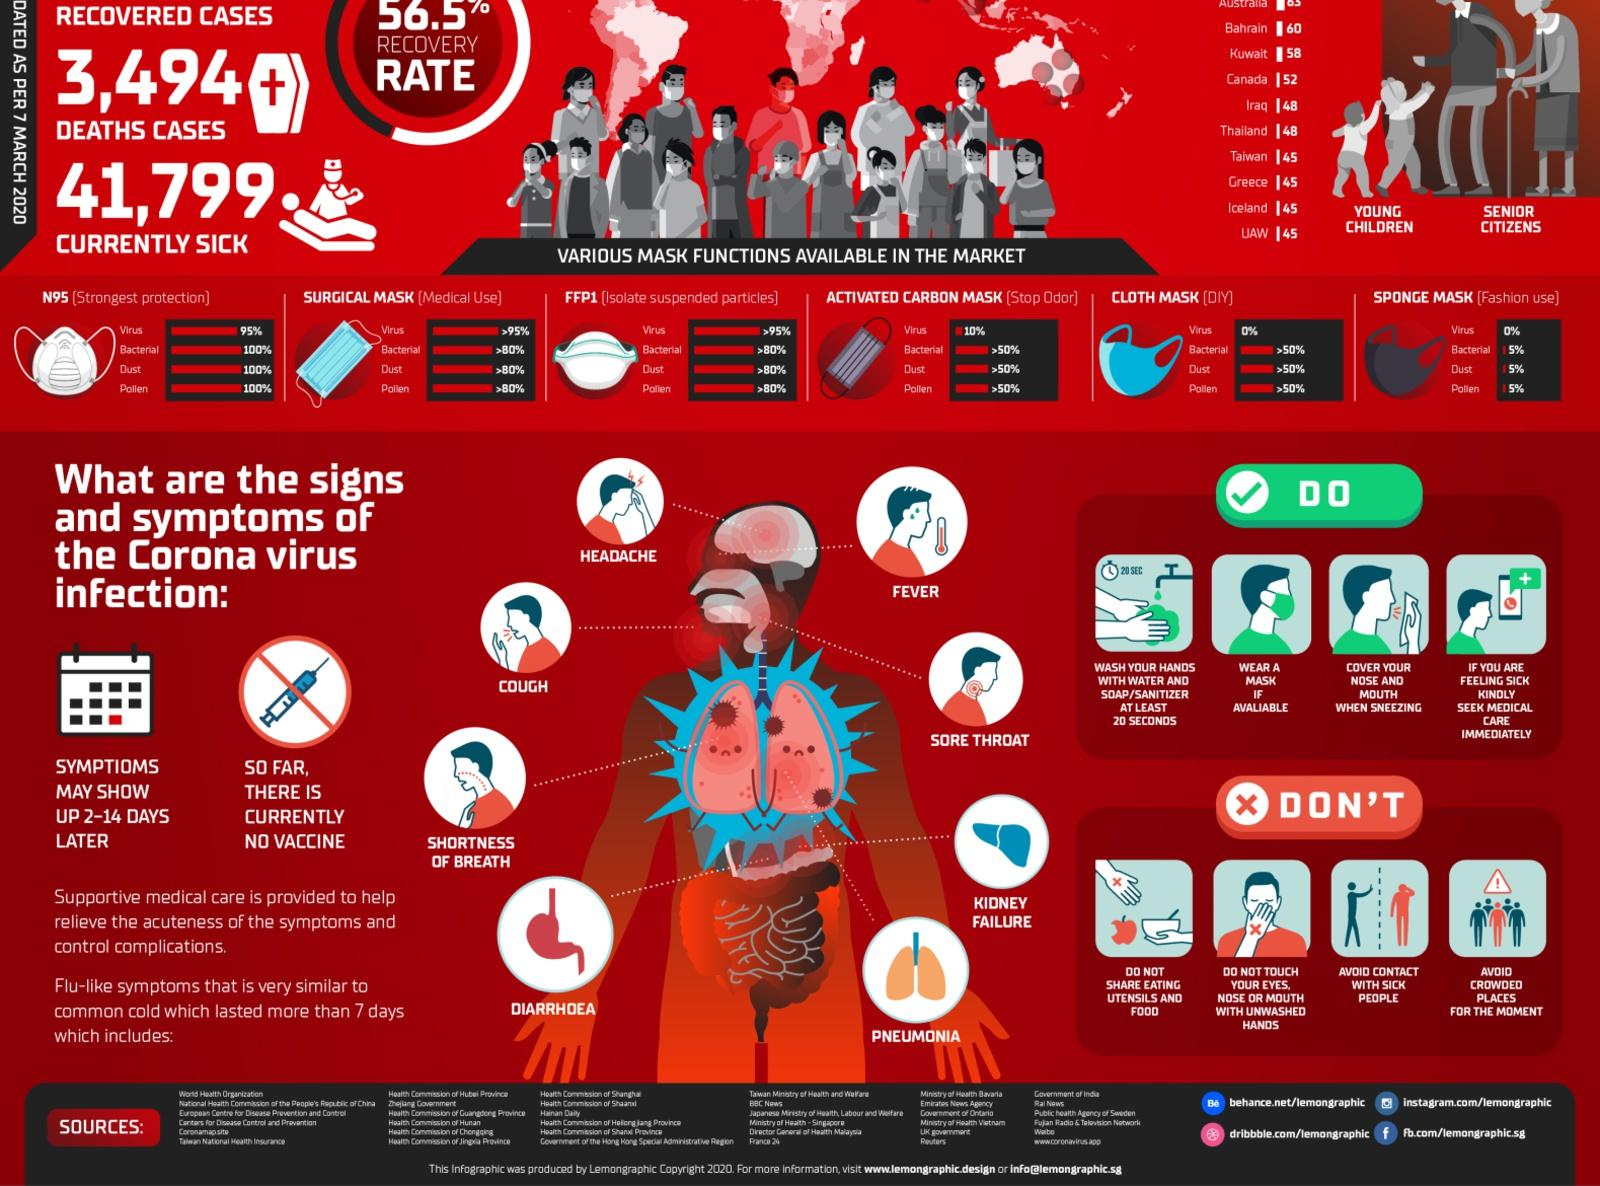Highlight a few significant elements in this photo. Eight symptoms are depicted in the image. There are six types of masks shown. The activated carbon mask offers a 10% level of protection against viruses. The cloth mask provides superior protection against bacteria compared to the sponge mask. The N95 mask provides the highest level of protection against bacteria among all masks. 